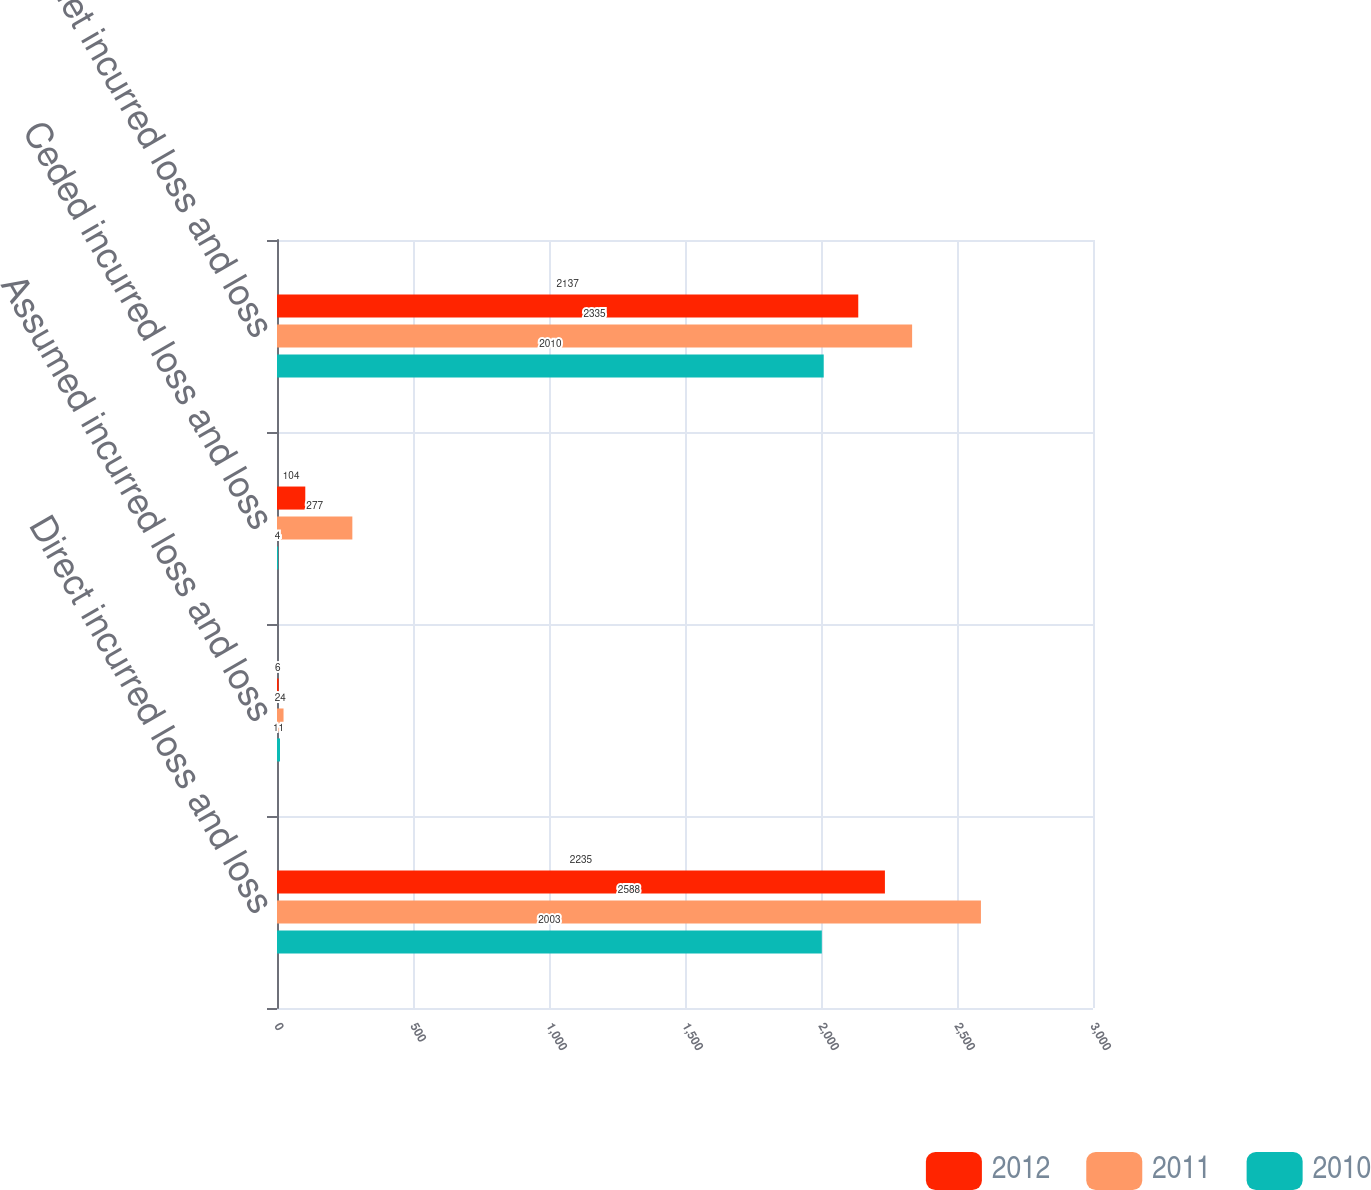<chart> <loc_0><loc_0><loc_500><loc_500><stacked_bar_chart><ecel><fcel>Direct incurred loss and loss<fcel>Assumed incurred loss and loss<fcel>Ceded incurred loss and loss<fcel>Net incurred loss and loss<nl><fcel>2012<fcel>2235<fcel>6<fcel>104<fcel>2137<nl><fcel>2011<fcel>2588<fcel>24<fcel>277<fcel>2335<nl><fcel>2010<fcel>2003<fcel>11<fcel>4<fcel>2010<nl></chart> 